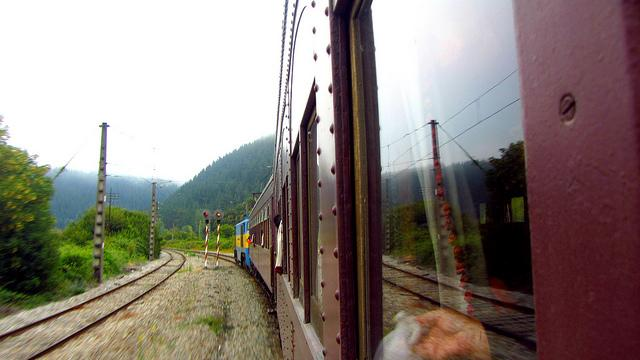Why is the train stopped? red light 